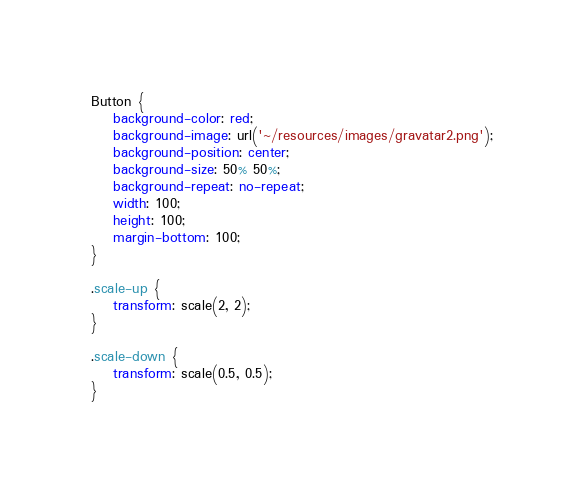<code> <loc_0><loc_0><loc_500><loc_500><_CSS_>Button {
    background-color: red;
    background-image: url('~/resources/images/gravatar2.png');
    background-position: center;
    background-size: 50% 50%;
    background-repeat: no-repeat;
    width: 100;
    height: 100;
    margin-bottom: 100;
}

.scale-up {
    transform: scale(2, 2);
}

.scale-down {
    transform: scale(0.5, 0.5);
}</code> 